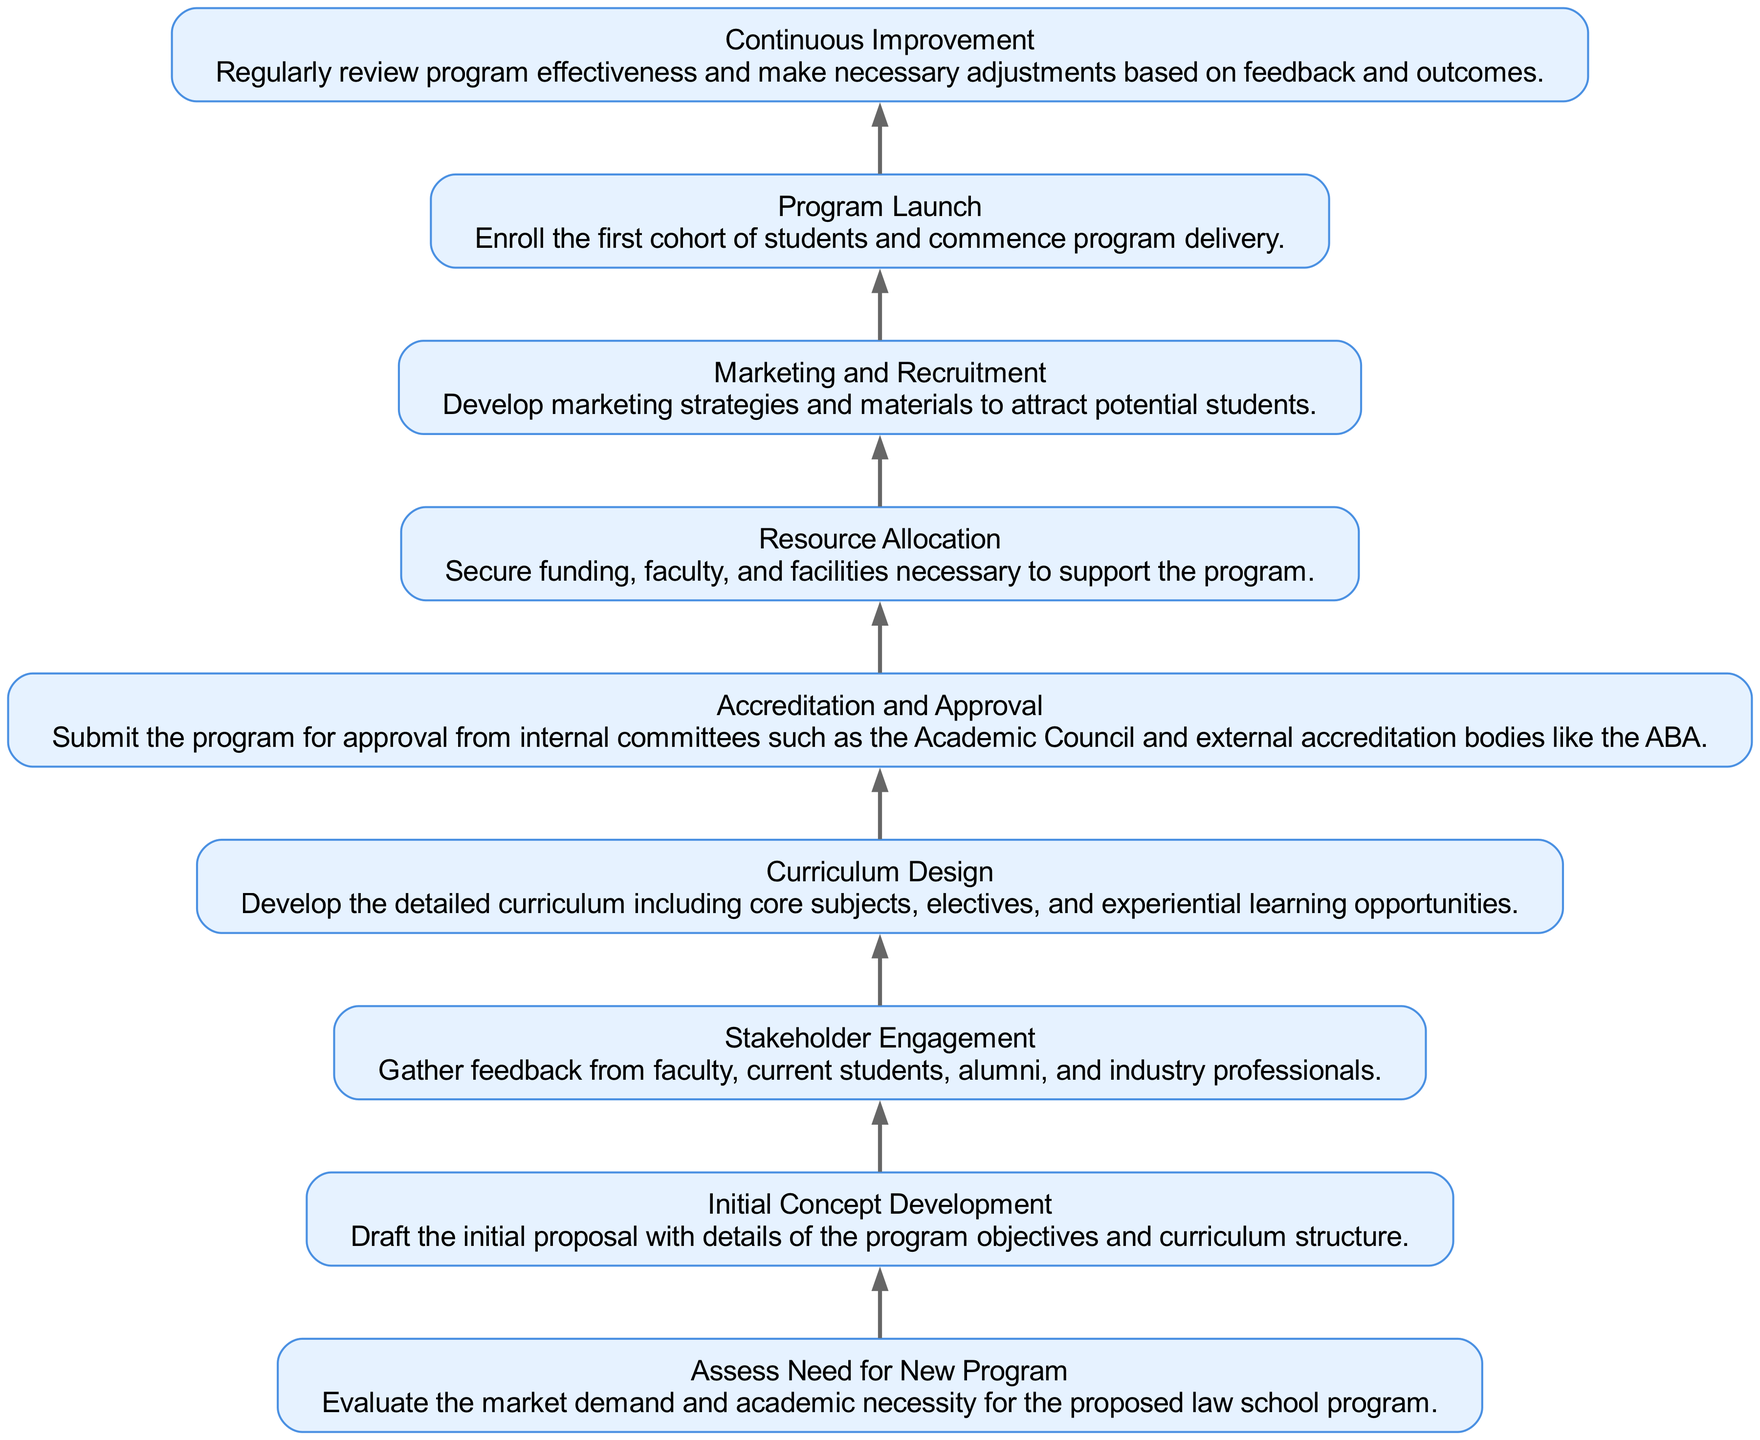What is the first step in the process? The first step in the process is "Assess Need for New Program," which identifies market demand and academic necessity.
Answer: Assess Need for New Program How many nodes are in the diagram? By counting each distinct step in the process, there are a total of 9 nodes illustrated in the diagram.
Answer: 9 What step comes immediately after "Curriculum Design"? The step that comes immediately after "Curriculum Design" is "Accreditation and Approval." This is the next logical phase following curriculum development.
Answer: Accreditation and Approval Which step depends on "Stakeholder Engagement"? The step that depends on "Stakeholder Engagement" is "Curriculum Design," as it requires input from stakeholders before finalizing the curriculum.
Answer: Curriculum Design What is the final step in the implementation process? The final step in the implementation process is "Continuous Improvement," which emphasizes ongoing review and adjustment of the program.
Answer: Continuous Improvement What are the dependencies for "Program Launch"? "Program Launch" depends on "Marketing and Recruitment," as the necessary outreach must occur before launching the program.
Answer: Marketing and Recruitment What step follows "Initial Concept Development"? The step that follows "Initial Concept Development" is "Stakeholder Engagement," where input is gathered from various stakeholders regarding the proposed program.
Answer: Stakeholder Engagement How many dependencies does "Resource Allocation" have? "Resource Allocation" has one dependency, which is "Accreditation and Approval," indicating that resources should be secured only after receiving necessary approvals.
Answer: 1 What does "Initial Concept Development" include? "Initial Concept Development" includes drafting the initial proposal with details of program objectives and curriculum structure as its primary focus.
Answer: Drafting the initial proposal 